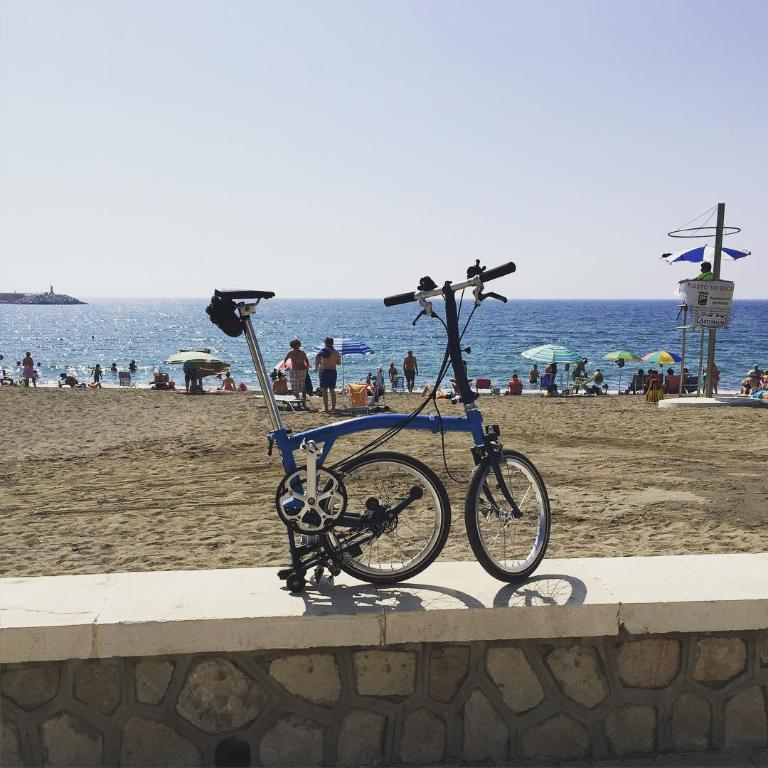What is the main object in the foreground of the image? There is a bicycle in the foreground of the image. What type of terrain is visible in the image? There is sand visible in the image. Where are the people located in the image? There are people on the side of a beach in the image. What can be seen in the background of the image? There is water visible in the image. What is the condition of the sky in the image? The sky is clear in the image. What type of question is being asked by the bicycle in the image? There is no indication in the image that the bicycle is asking a question or capable of doing so. 